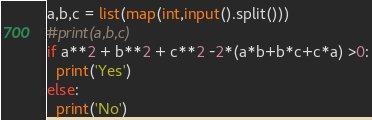<code> <loc_0><loc_0><loc_500><loc_500><_Python_>a,b,c = list(map(int,input().split()))
#print(a,b,c)
if a**2 + b**2 + c**2 -2*(a*b+b*c+c*a) >0:
  print('Yes')
else:
  print('No')</code> 